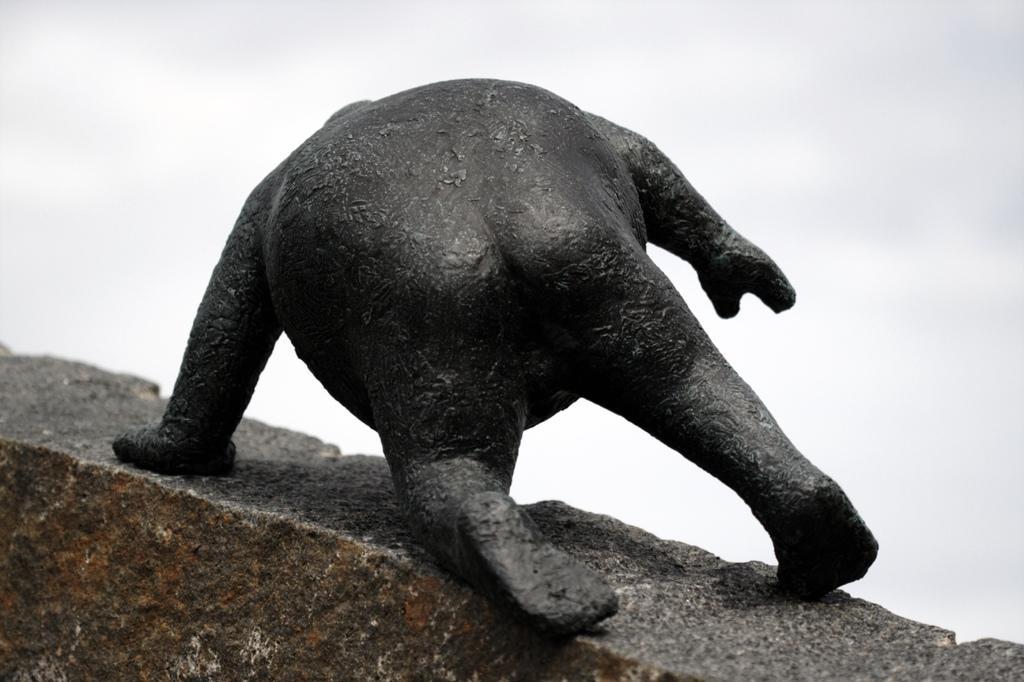In one or two sentences, can you explain what this image depicts? In this image we can see an animal on the stone. On the backside we can see the sky which looks cloudy. 